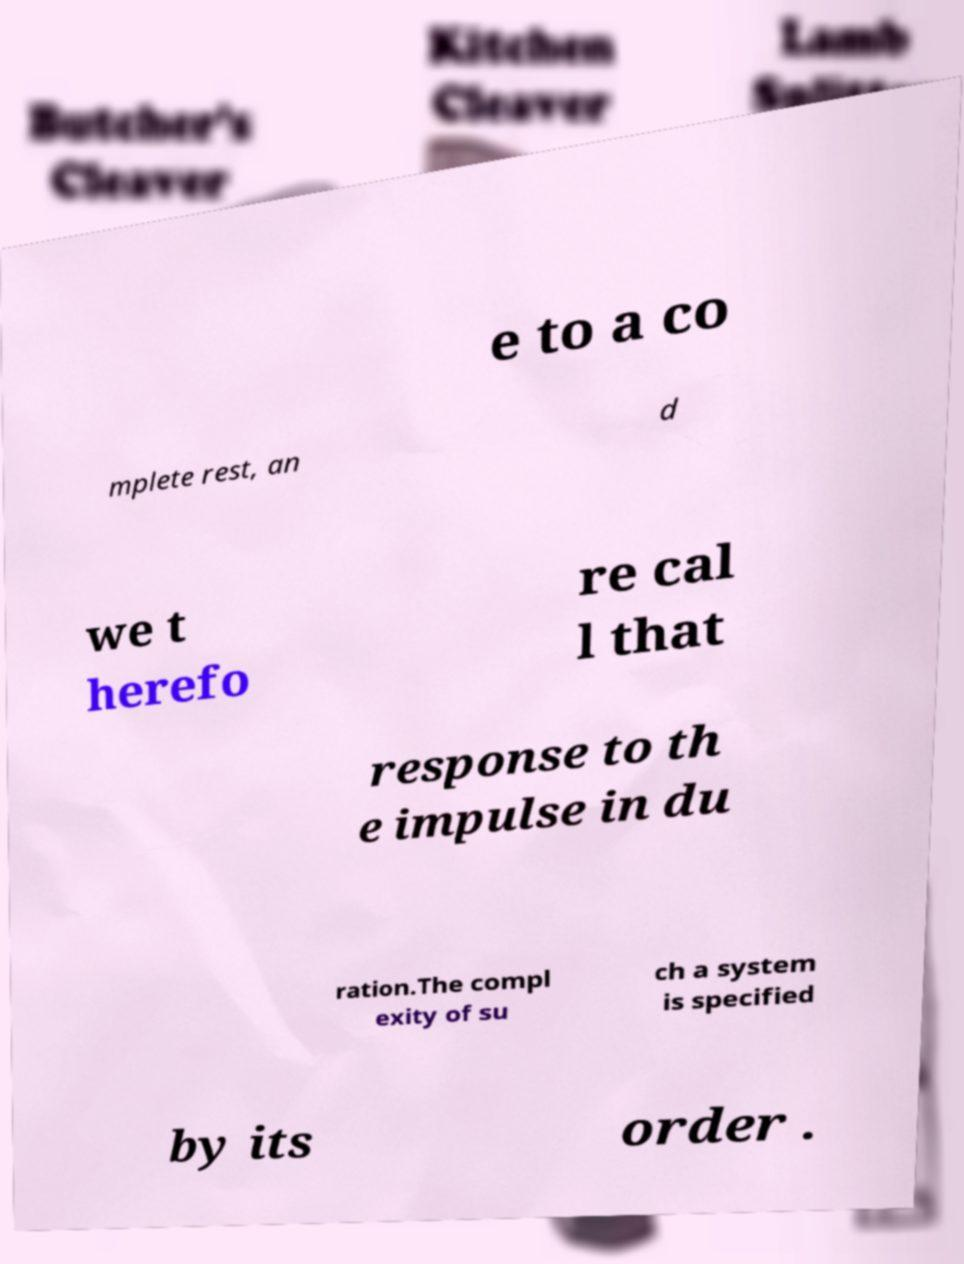For documentation purposes, I need the text within this image transcribed. Could you provide that? e to a co mplete rest, an d we t herefo re cal l that response to th e impulse in du ration.The compl exity of su ch a system is specified by its order . 